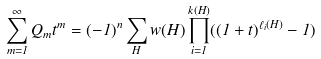Convert formula to latex. <formula><loc_0><loc_0><loc_500><loc_500>\sum _ { m = 1 } ^ { \infty } Q _ { m } t ^ { m } = ( - 1 ) ^ { n } \sum _ { H } w ( H ) \prod _ { i = 1 } ^ { k ( H ) } ( ( 1 + t ) ^ { \ell _ { i } ( H ) } - 1 )</formula> 